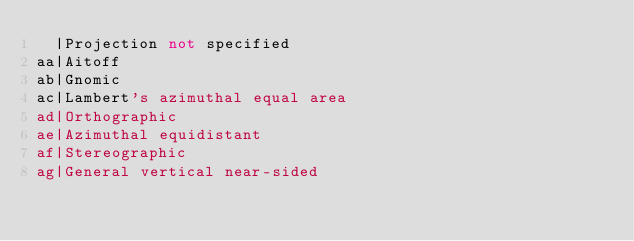<code> <loc_0><loc_0><loc_500><loc_500><_SQL_>  |Projection not specified
aa|Aitoff
ab|Gnomic
ac|Lambert's azimuthal equal area
ad|Orthographic
ae|Azimuthal equidistant
af|Stereographic
ag|General vertical near-sided</code> 